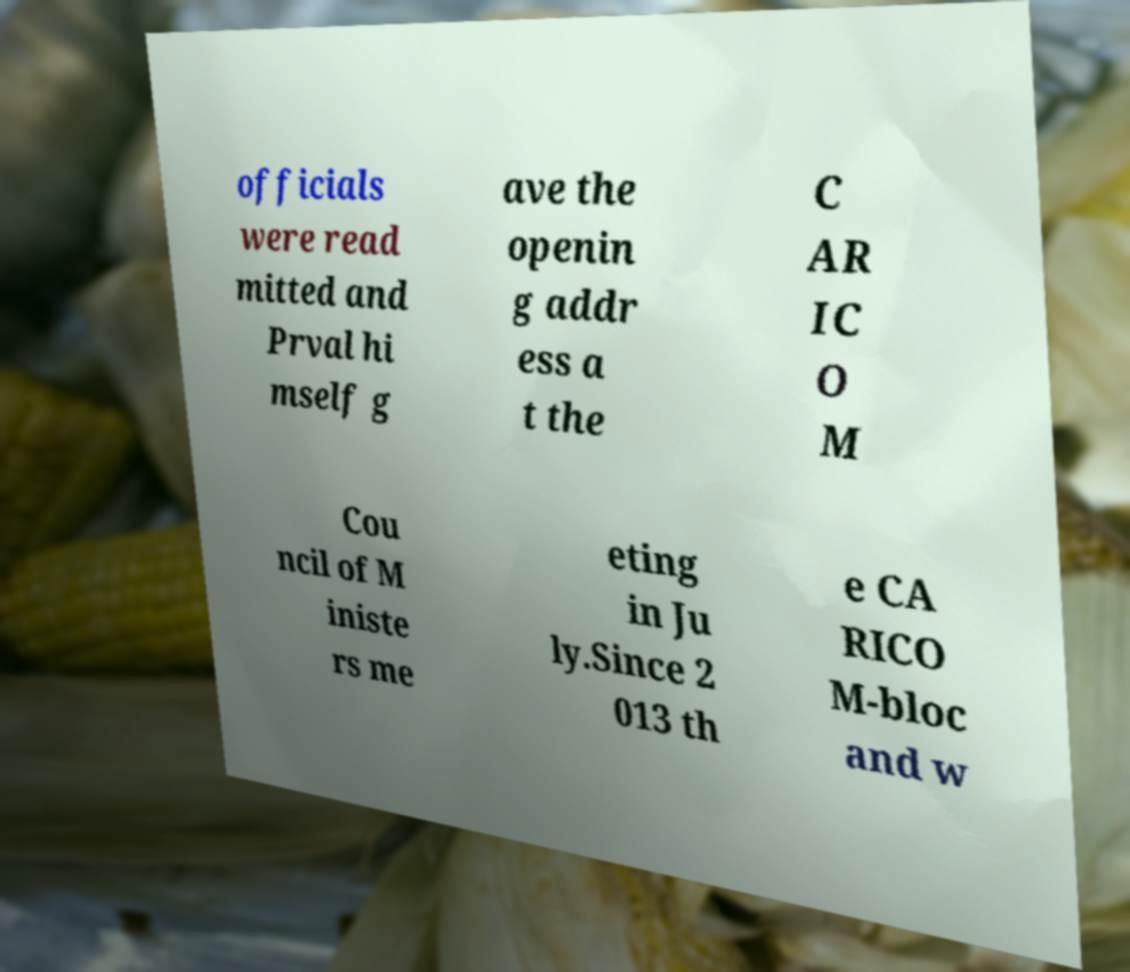Please identify and transcribe the text found in this image. officials were read mitted and Prval hi mself g ave the openin g addr ess a t the C AR IC O M Cou ncil of M iniste rs me eting in Ju ly.Since 2 013 th e CA RICO M-bloc and w 